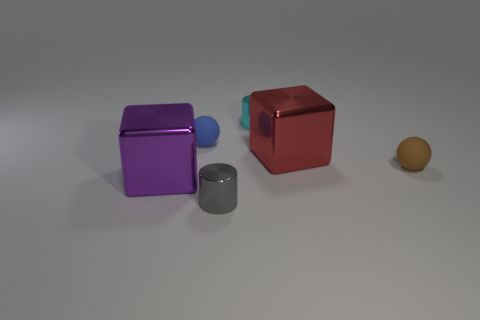Are there an equal number of cyan shiny things that are in front of the large purple cube and brown shiny balls?
Provide a short and direct response. Yes. What is the cube behind the thing on the right side of the big object that is behind the large purple object made of?
Keep it short and to the point. Metal. How many things are either cylinders that are to the right of the small gray metallic cylinder or tiny blue balls?
Your answer should be compact. 2. How many objects are cylinders or small spheres that are to the right of the cyan cylinder?
Your answer should be compact. 3. There is a large object left of the big object behind the purple thing; how many small cyan objects are to the right of it?
Your response must be concise. 1. What is the material of the blue sphere that is the same size as the cyan thing?
Offer a terse response. Rubber. Is there a red shiny object that has the same size as the cyan shiny object?
Give a very brief answer. No. What is the color of the big object that is behind the block in front of the brown ball?
Keep it short and to the point. Red. There is a tiny gray metal object that is to the left of the shiny thing behind the small sphere that is behind the red object; what shape is it?
Give a very brief answer. Cylinder. What number of tiny cylinders are made of the same material as the large purple cube?
Provide a short and direct response. 2. 